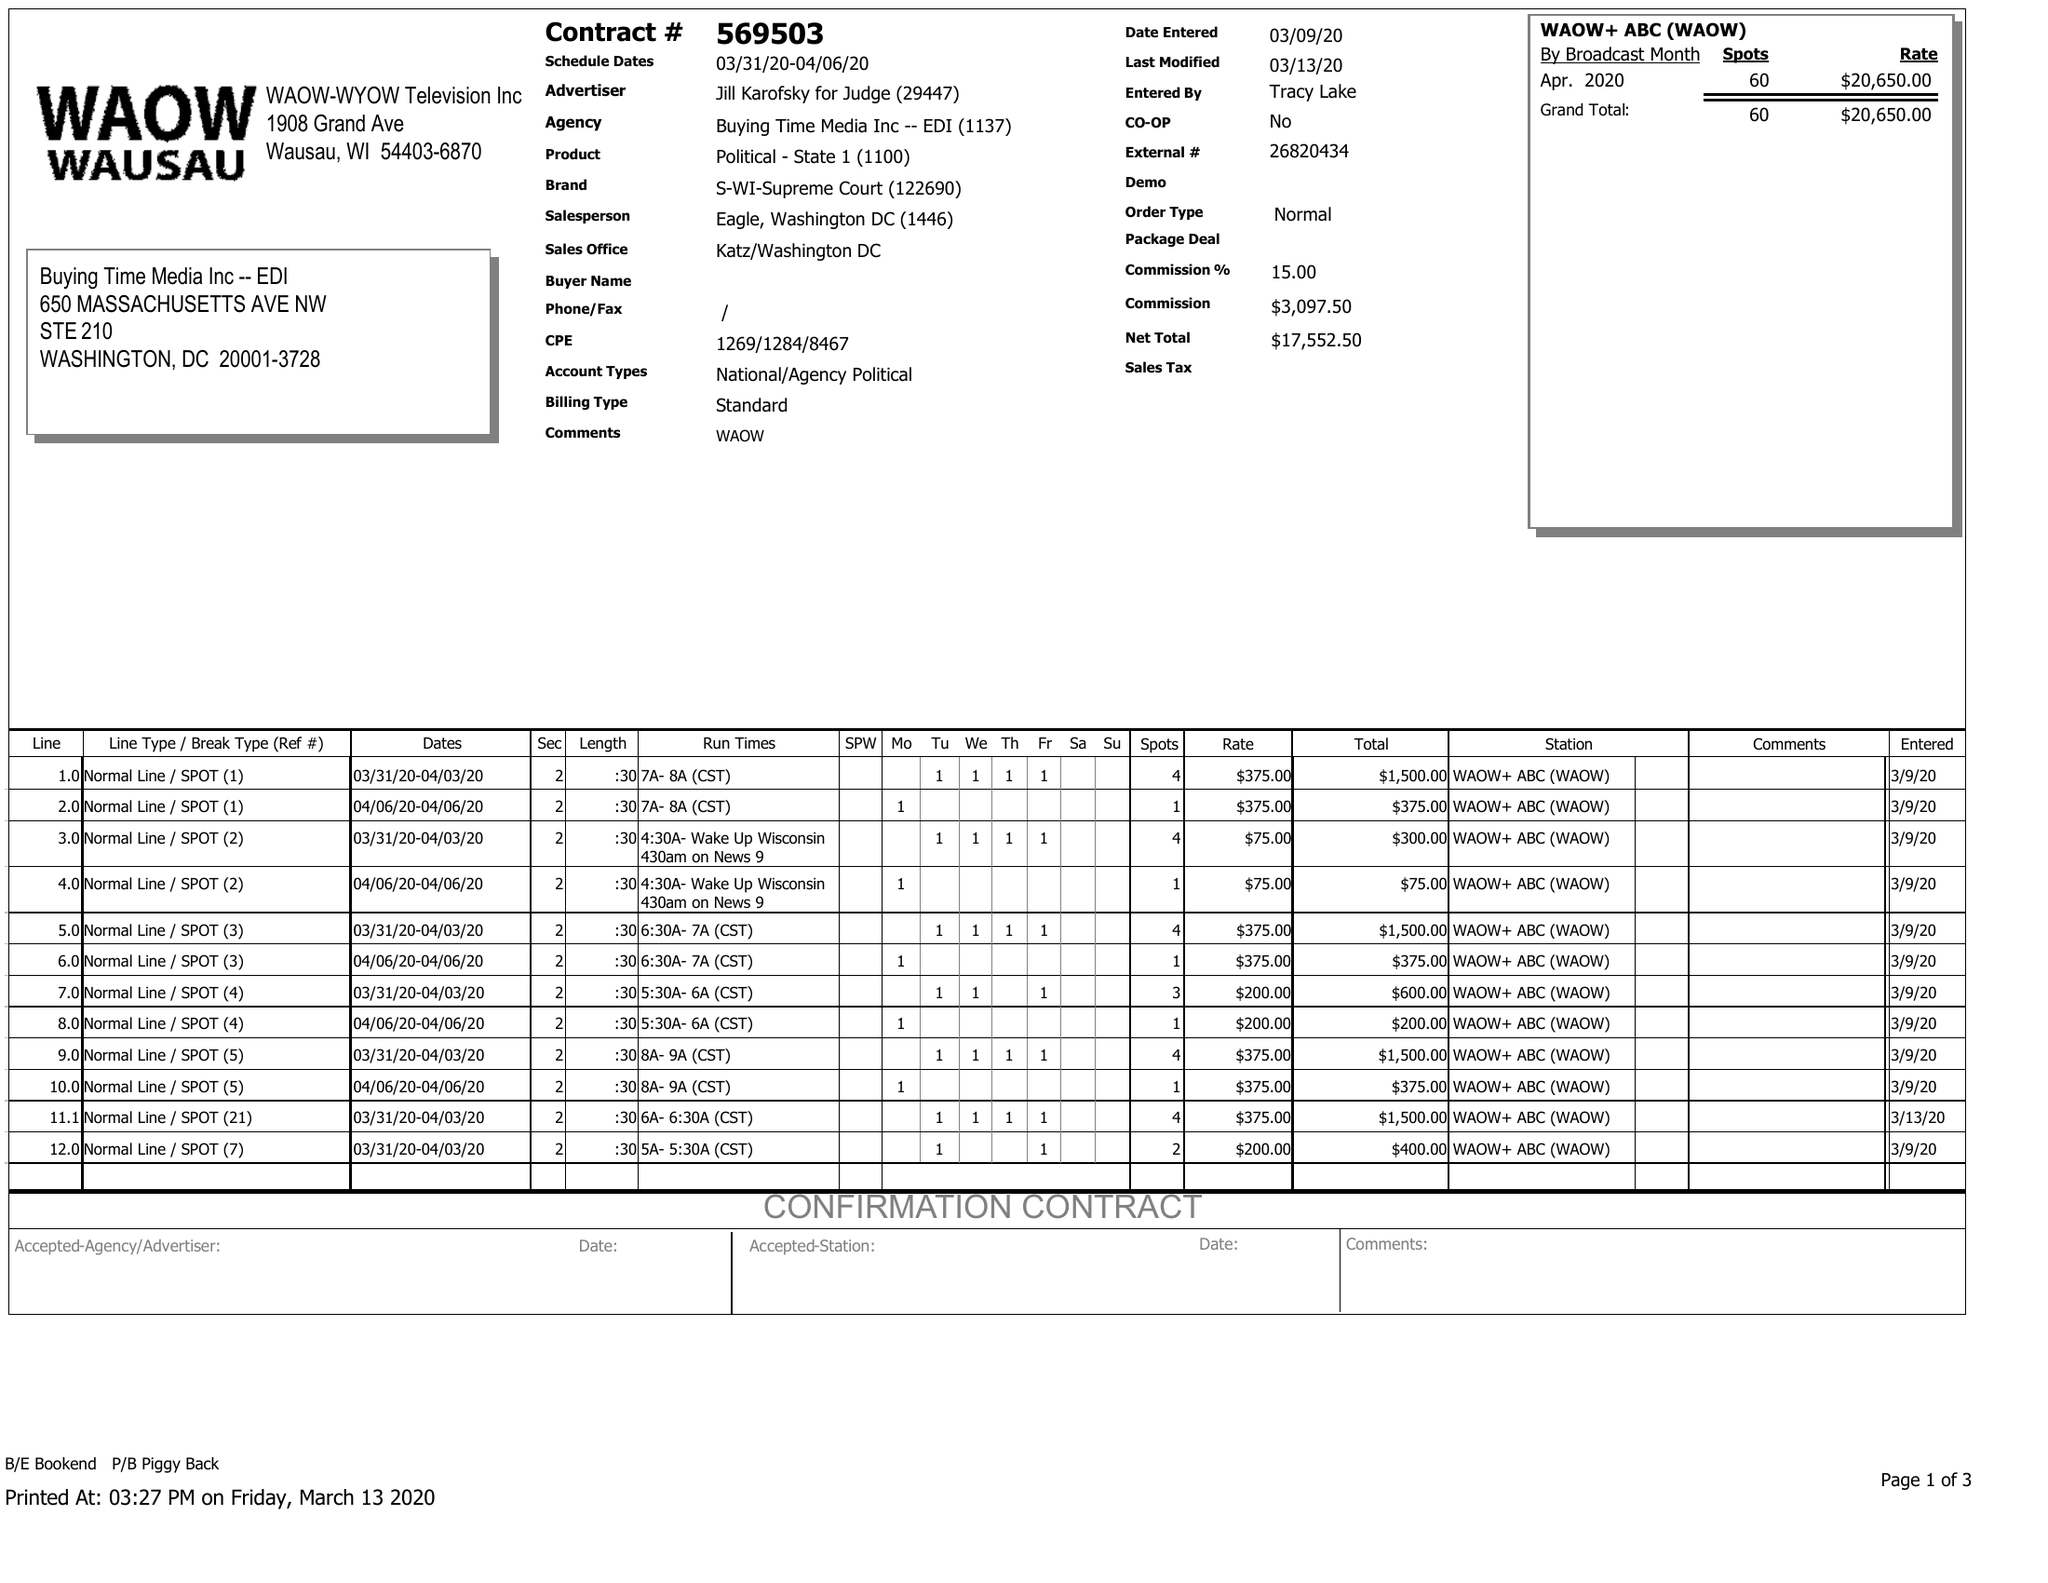What is the value for the flight_to?
Answer the question using a single word or phrase. 04/06/20 